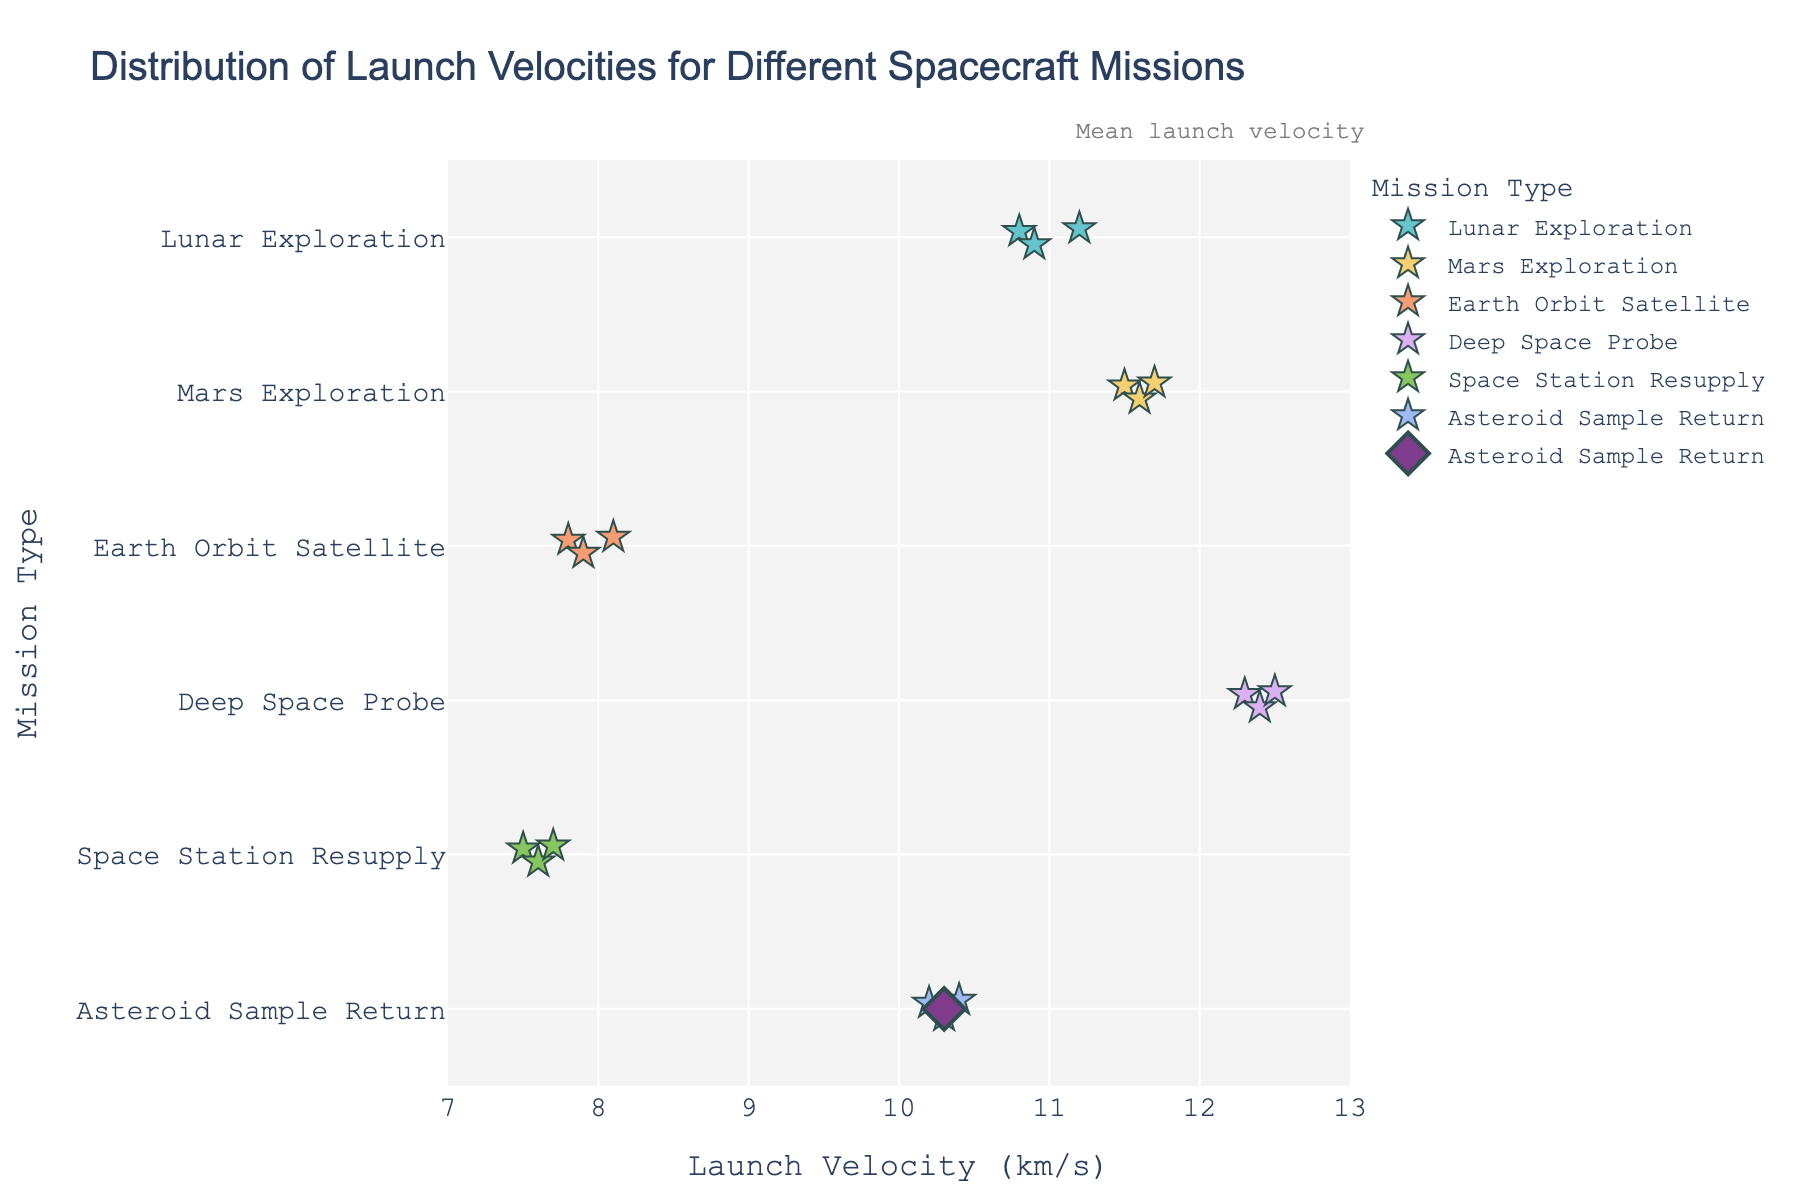How many mission types are displayed in the plot? There are six distinct mission types listed along the y-axis: Lunar Exploration, Mars Exploration, Earth Orbit Satellite, Deep Space Probe, Space Station Resupply, and Asteroid Sample Return.
Answer: 6 What is the range of launch velocities for Mars Exploration missions? By observing the plot, the launch velocities for Mars Exploration missions range from 11.5 km/s to 11.7 km/s.
Answer: 11.5 to 11.7 km/s How does the launch velocity of Space Station Resupply missions compare to Earth Orbit Satellite missions? The launch velocities for Space Station Resupply missions (7.5 to 7.7 km/s) are slightly lower than those for Earth Orbit Satellite missions (7.8 to 8.1 km/s).
Answer: Space Station Resupply velocities are lower Which mission type has the highest mean launch velocity? The plot includes mean points for each mission type. The mission type with the highest mean point is Deep Space Probe.
Answer: Deep Space Probe Are there any overlapping launch velocities between Lunar Exploration and Asteroid Sample Return missions? By looking at the ranges on the plot, Lunar Exploration missions have launch velocities ranging from 10.8 to 11.2 km/s, while Asteroid Sample Return missions range from 10.2 to 10.4 km/s. There is no overlap between these two ranges.
Answer: No 